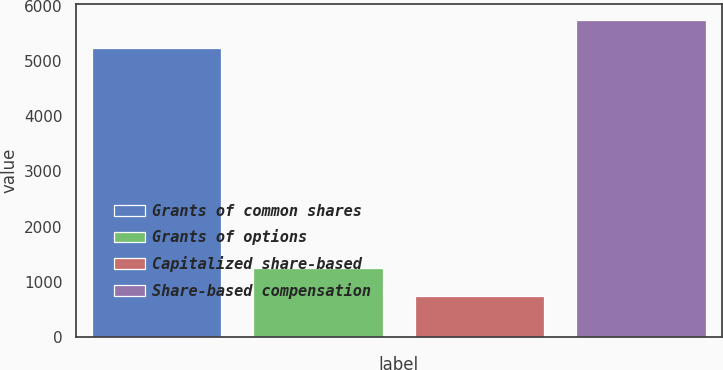Convert chart to OTSL. <chart><loc_0><loc_0><loc_500><loc_500><bar_chart><fcel>Grants of common shares<fcel>Grants of options<fcel>Capitalized share-based<fcel>Share-based compensation<nl><fcel>5232<fcel>1255<fcel>745<fcel>5742<nl></chart> 